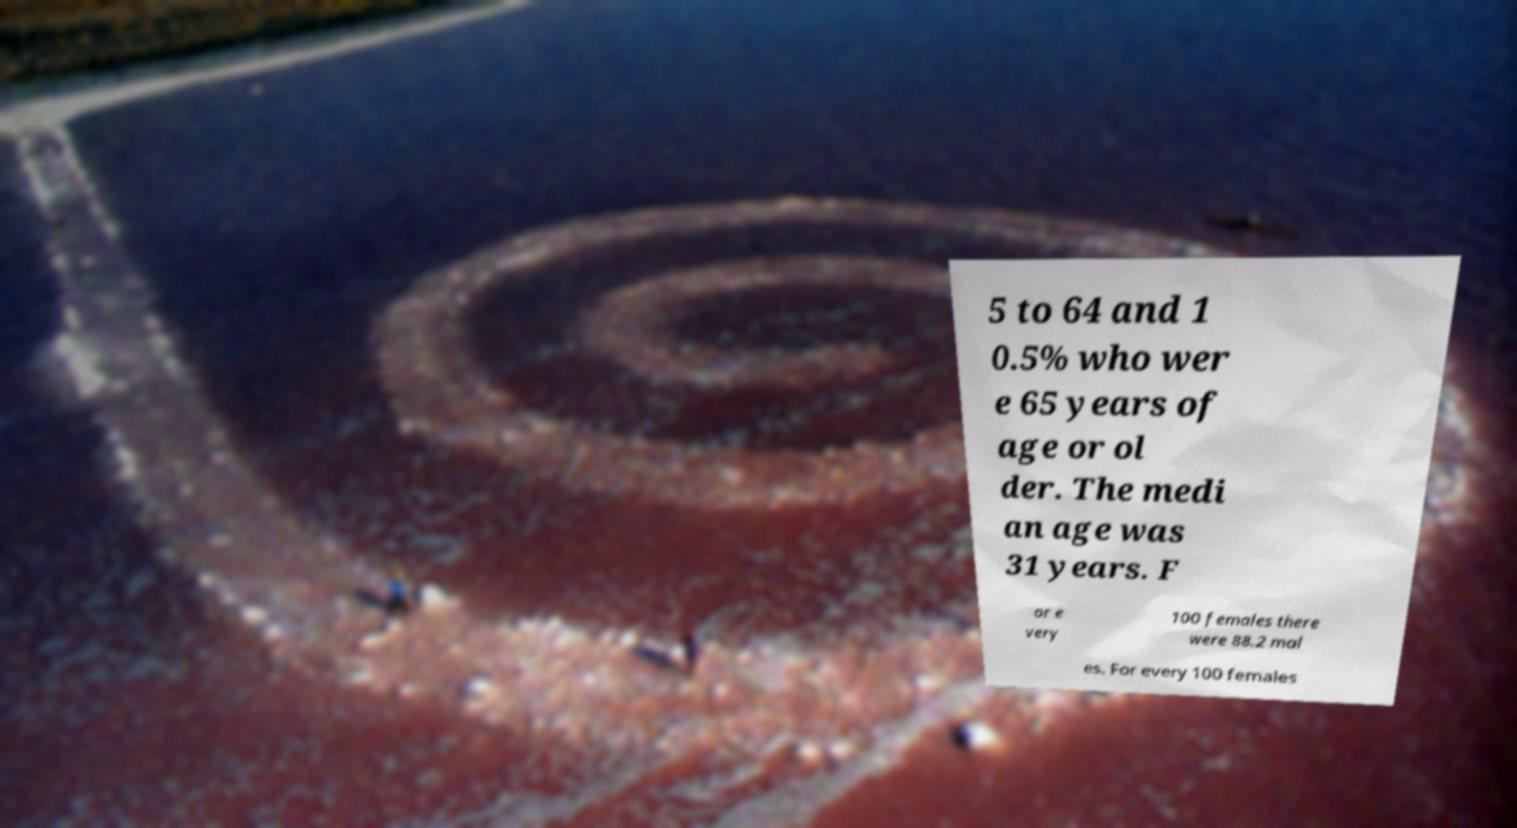Could you extract and type out the text from this image? 5 to 64 and 1 0.5% who wer e 65 years of age or ol der. The medi an age was 31 years. F or e very 100 females there were 88.2 mal es. For every 100 females 